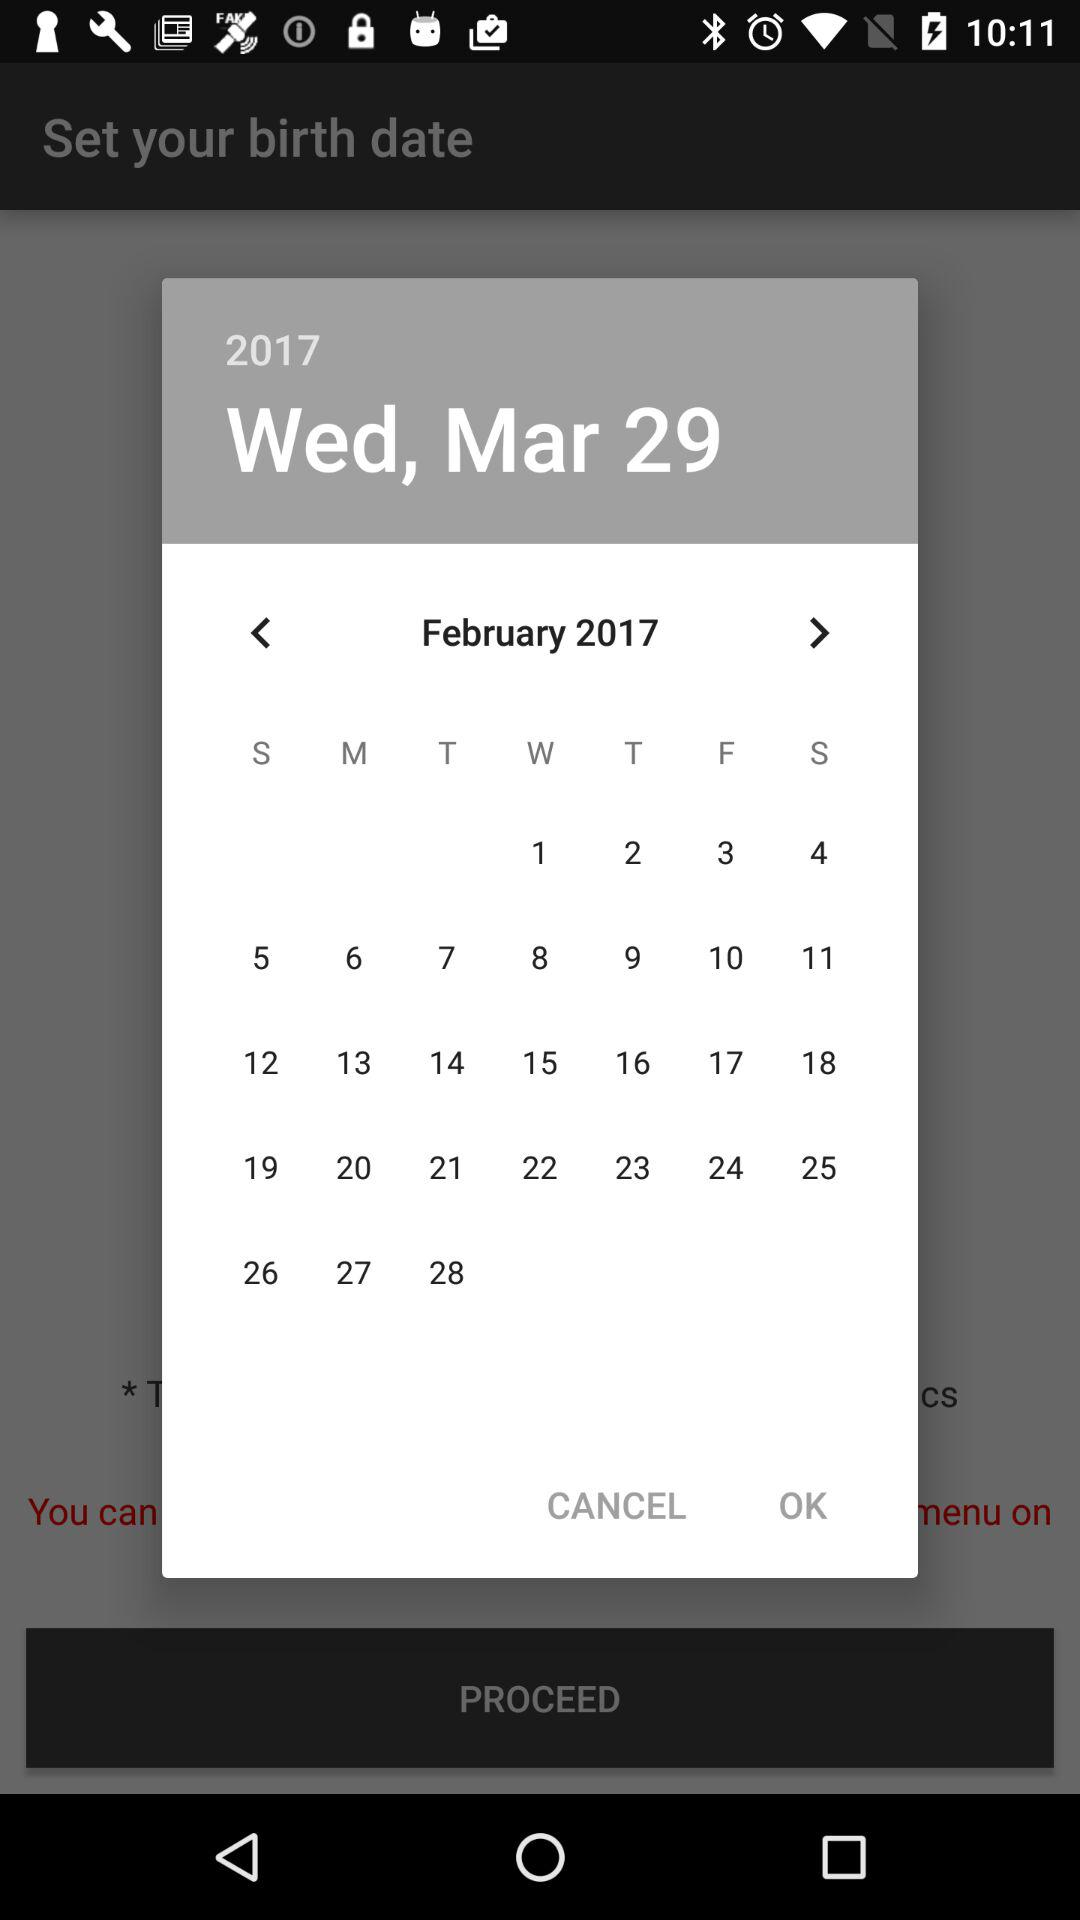What is the mentioned month on the calendar? The mentioned months are March and February. 